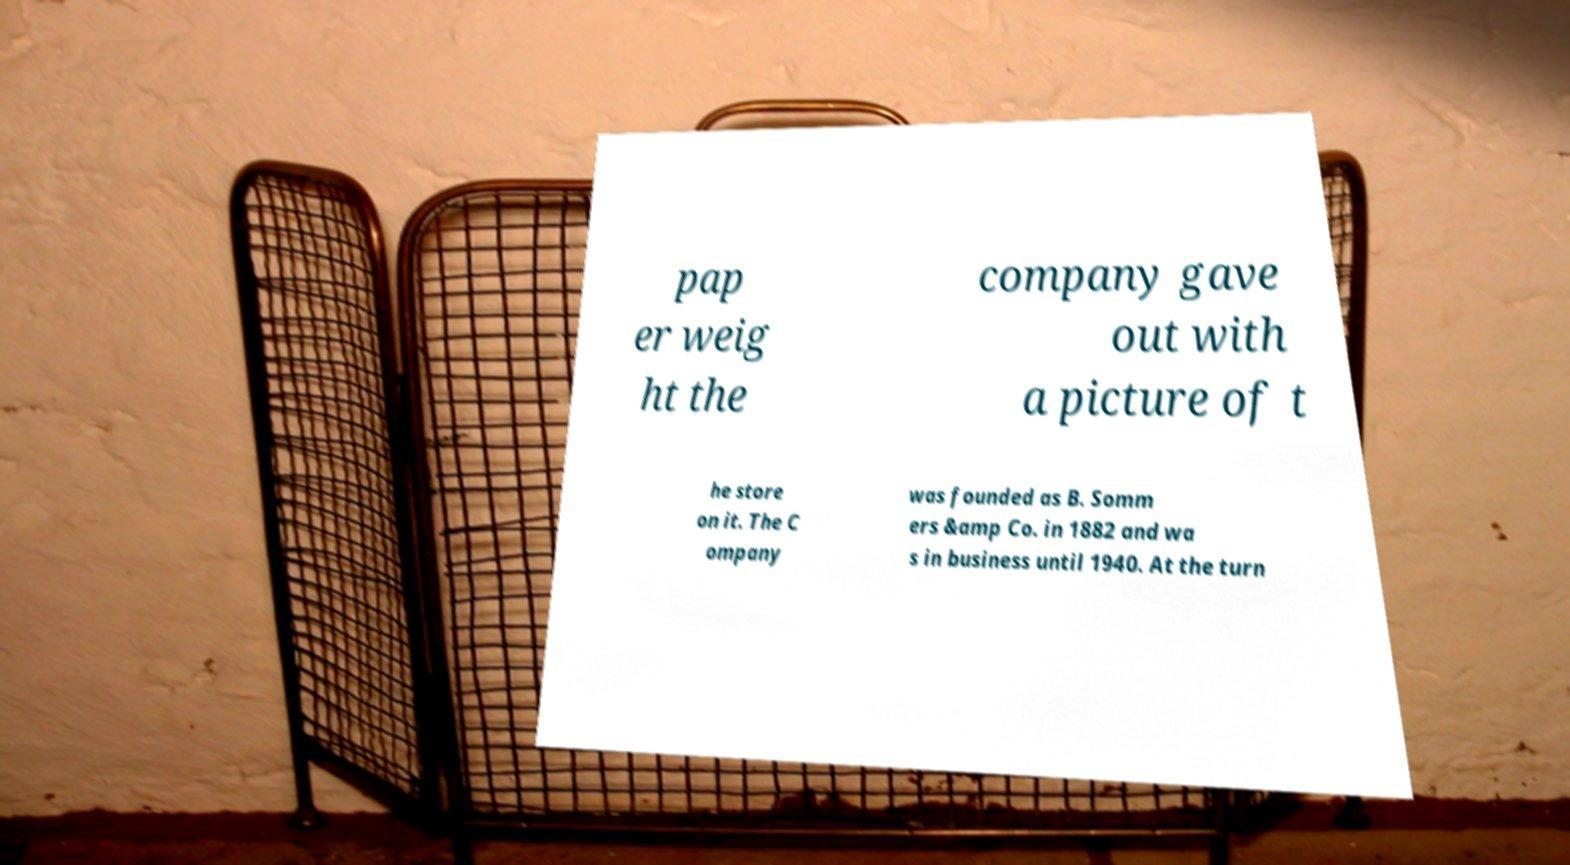There's text embedded in this image that I need extracted. Can you transcribe it verbatim? pap er weig ht the company gave out with a picture of t he store on it. The C ompany was founded as B. Somm ers &amp Co. in 1882 and wa s in business until 1940. At the turn 